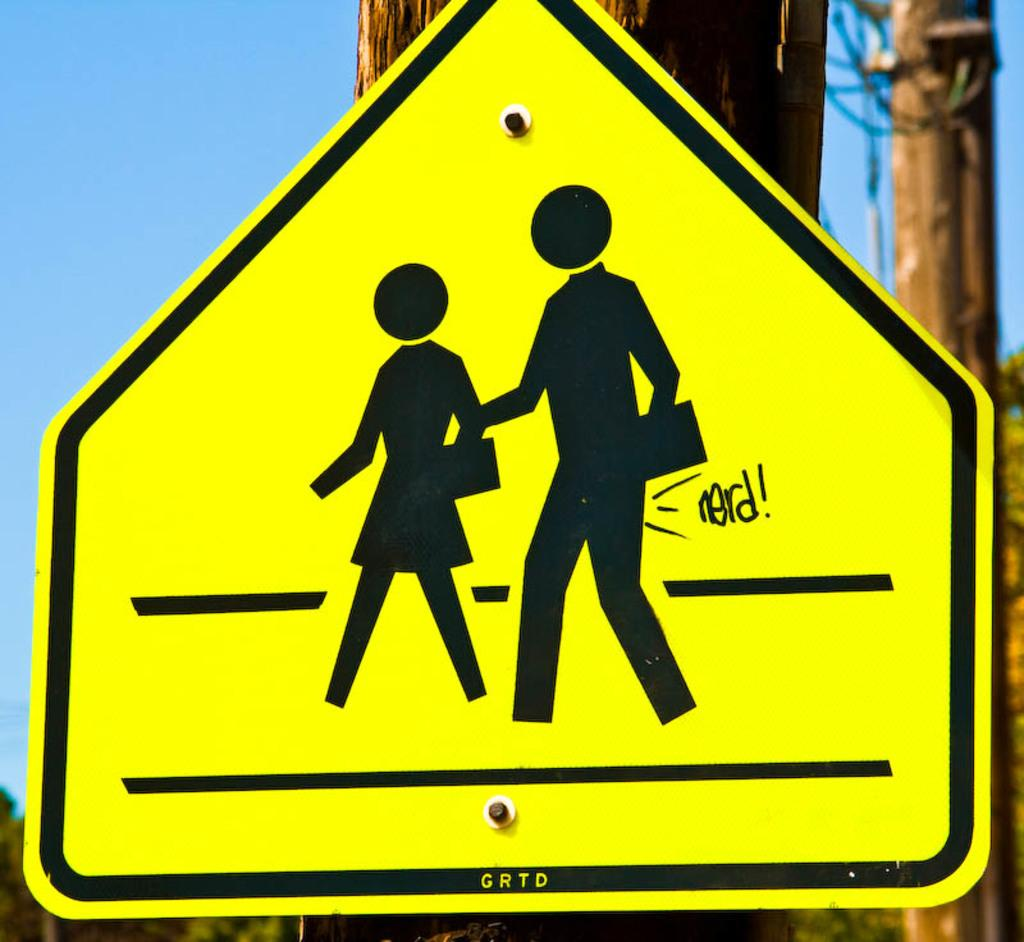Provide a one-sentence caption for the provided image. A close up picture of a crosswalk sign that has "nerd!" on it. 